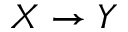Convert formula to latex. <formula><loc_0><loc_0><loc_500><loc_500>X \rightarrow Y</formula> 